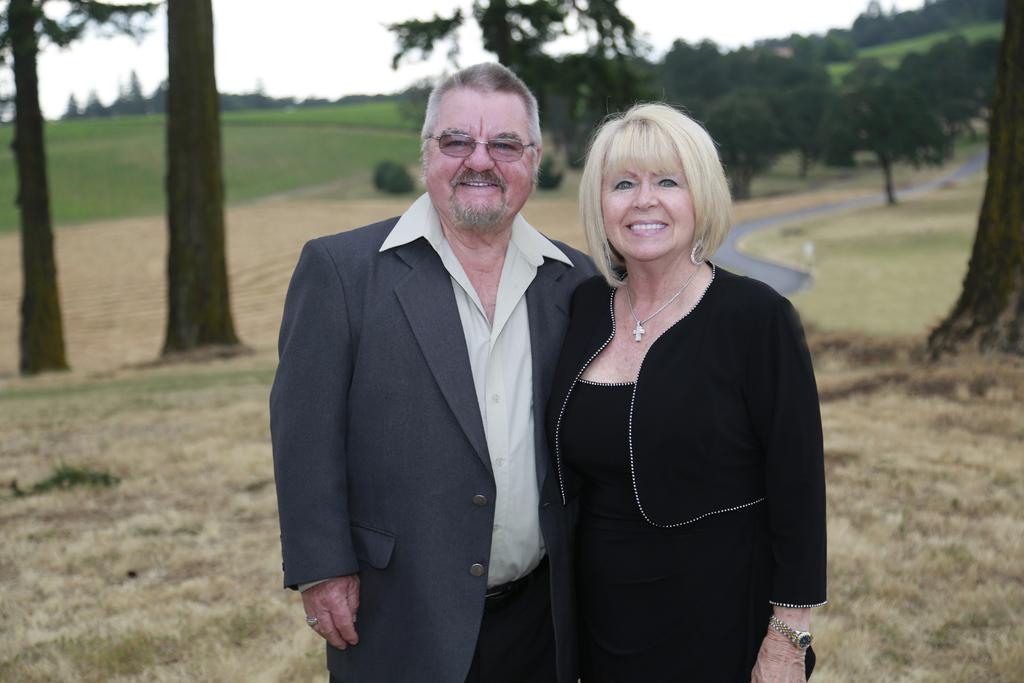How many people are present in the image? There are two people standing in the image. What can be seen under the people's feet? The ground is visible in the image. What type of vegetation is present in the image? There is grass in the image. What else can be seen in the background of the image? There are trees in the image. What is visible above the people and trees? The sky is visible in the image. What type of metal can be seen growing among the grass in the image? There is no metal visible in the image; it features two people, grass, trees, and the sky. 